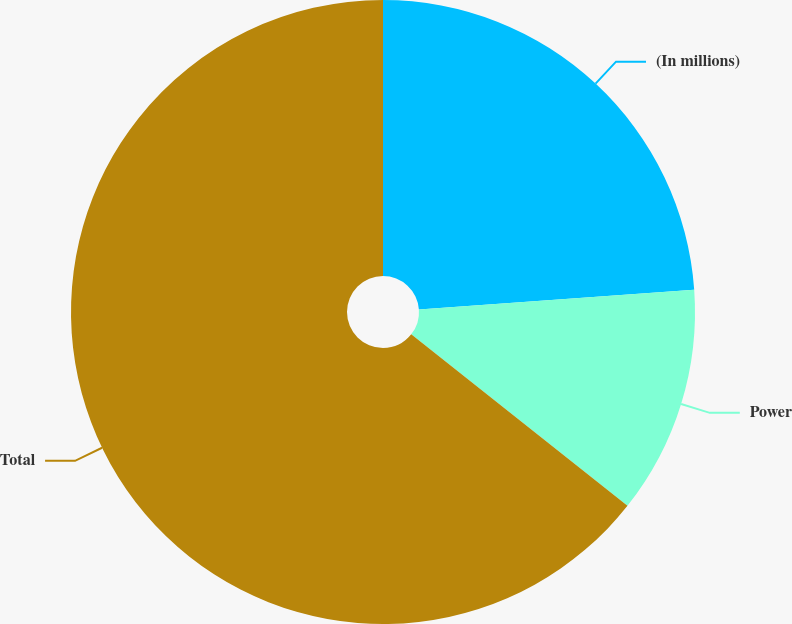Convert chart to OTSL. <chart><loc_0><loc_0><loc_500><loc_500><pie_chart><fcel>(In millions)<fcel>Power<fcel>Total<nl><fcel>23.86%<fcel>11.81%<fcel>64.33%<nl></chart> 